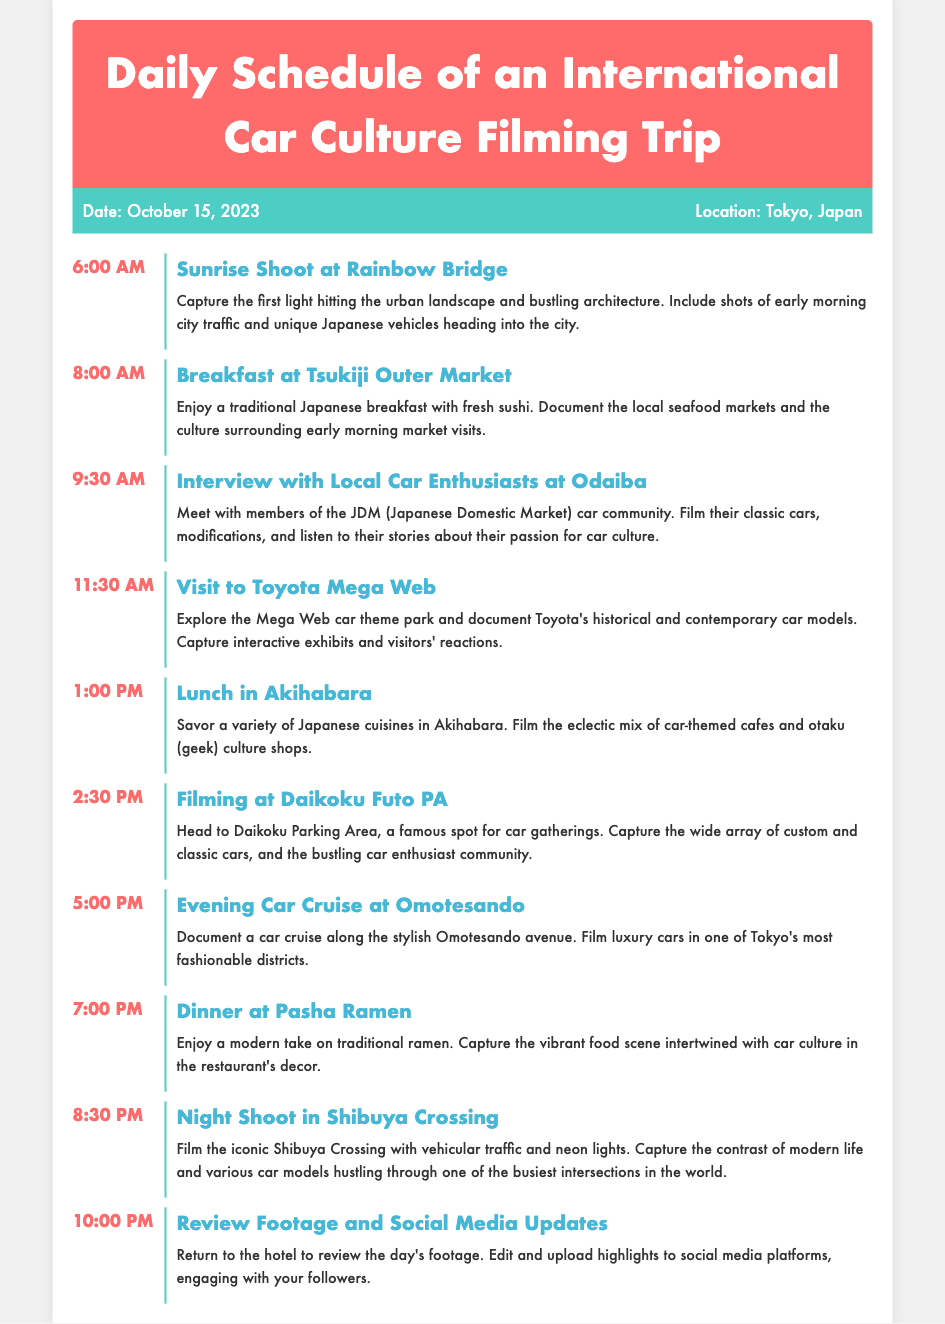What time does the sunrise shoot begin? The sunrise shoot begins at 6:00 AM, as stated in the schedule section of the document.
Answer: 6:00 AM What activity occurs at 9:30 AM? At 9:30 AM, there is an interview with local car enthusiasts at Odaiba, as listed in the schedule.
Answer: Interview with Local Car Enthusiasts at Odaiba What is the location for lunch? The location for lunch is Akihabara, as mentioned in the document.
Answer: Akihabara How many activities are scheduled before dinner? There are six activities scheduled before dinner at 7:00 PM.
Answer: 6 What is the last activity of the day? The last activity of the day is to review footage and social media updates at the hotel.
Answer: Review Footage and Social Media Updates Which location is associated with the evening car cruise? The evening car cruise is associated with Omotesando, as indicated in the schedule.
Answer: Omotesando What type of cuisine is served at Pasha Ramen? Modern ramen is served at Pasha Ramen, according to the dinner activity description.
Answer: Ramen What time does the night shoot in Shibuya Crossing start? The night shoot in Shibuya Crossing starts at 8:30 PM, as outlined in the timetable.
Answer: 8:30 PM 